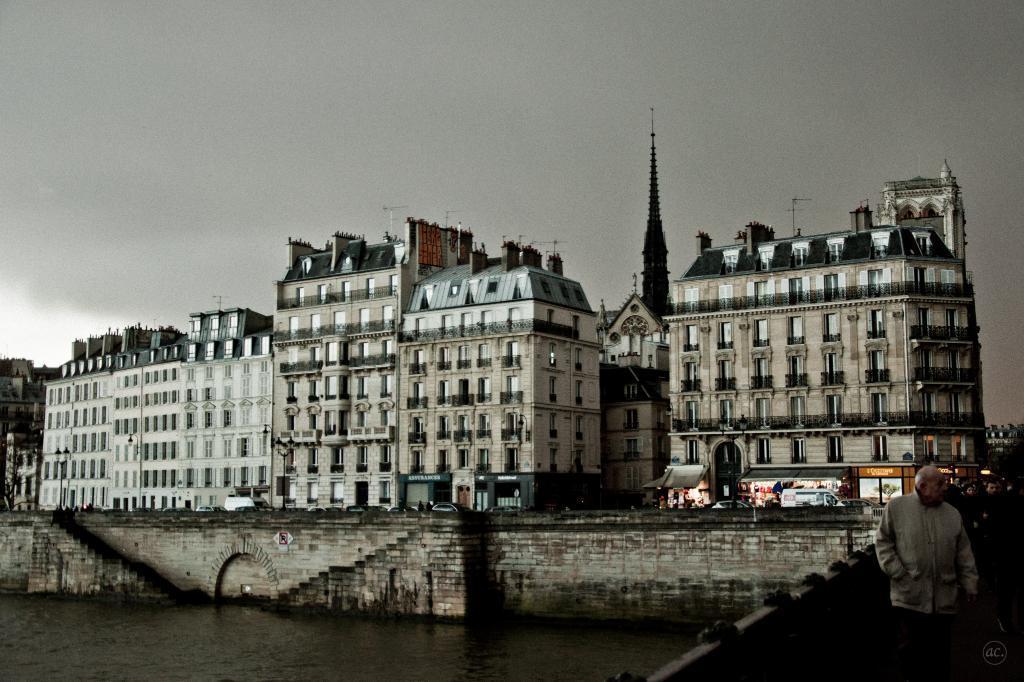Describe this image in one or two sentences. These are the buildings with windows. I can see few vehicles on the road. Here is the water flowing. I think this is the bridge. I can see few people standing. These are the stairs. 